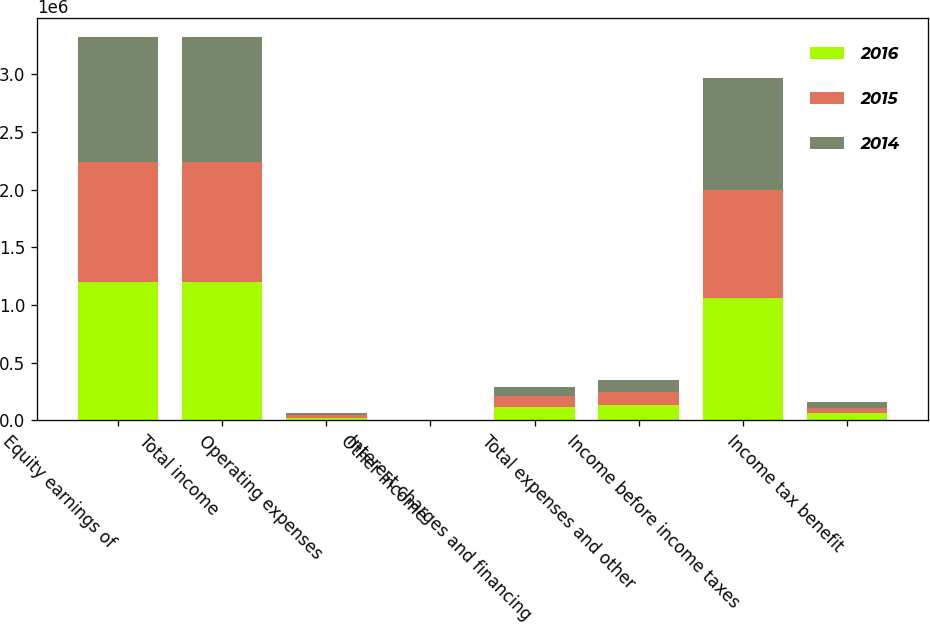<chart> <loc_0><loc_0><loc_500><loc_500><stacked_bar_chart><ecel><fcel>Equity earnings of<fcel>Total income<fcel>Operating expenses<fcel>Other income<fcel>Interest charges and financing<fcel>Total expenses and other<fcel>Income before income taxes<fcel>Income tax benefit<nl><fcel>2016<fcel>1.19856e+06<fcel>1.19856e+06<fcel>22128<fcel>3047<fcel>115473<fcel>134554<fcel>1.064e+06<fcel>59377<nl><fcel>2015<fcel>1.04579e+06<fcel>1.04579e+06<fcel>19865<fcel>1242<fcel>91801<fcel>110424<fcel>935364<fcel>49121<nl><fcel>2014<fcel>1.07771e+06<fcel>1.07771e+06<fcel>19756<fcel>537<fcel>84830<fcel>104049<fcel>973665<fcel>47641<nl></chart> 